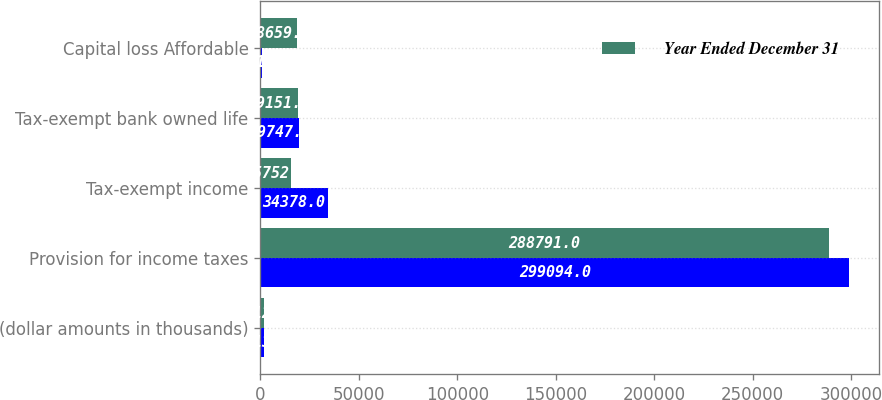<chart> <loc_0><loc_0><loc_500><loc_500><stacked_bar_chart><ecel><fcel>(dollar amounts in thousands)<fcel>Provision for income taxes<fcel>Tax-exempt income<fcel>Tax-exempt bank owned life<fcel>Capital loss Affordable<nl><fcel>nan<fcel>2013<fcel>299094<fcel>34378<fcel>19747<fcel>961<nl><fcel>Year Ended December 31<fcel>2012<fcel>288791<fcel>15752<fcel>19151<fcel>18659<nl></chart> 